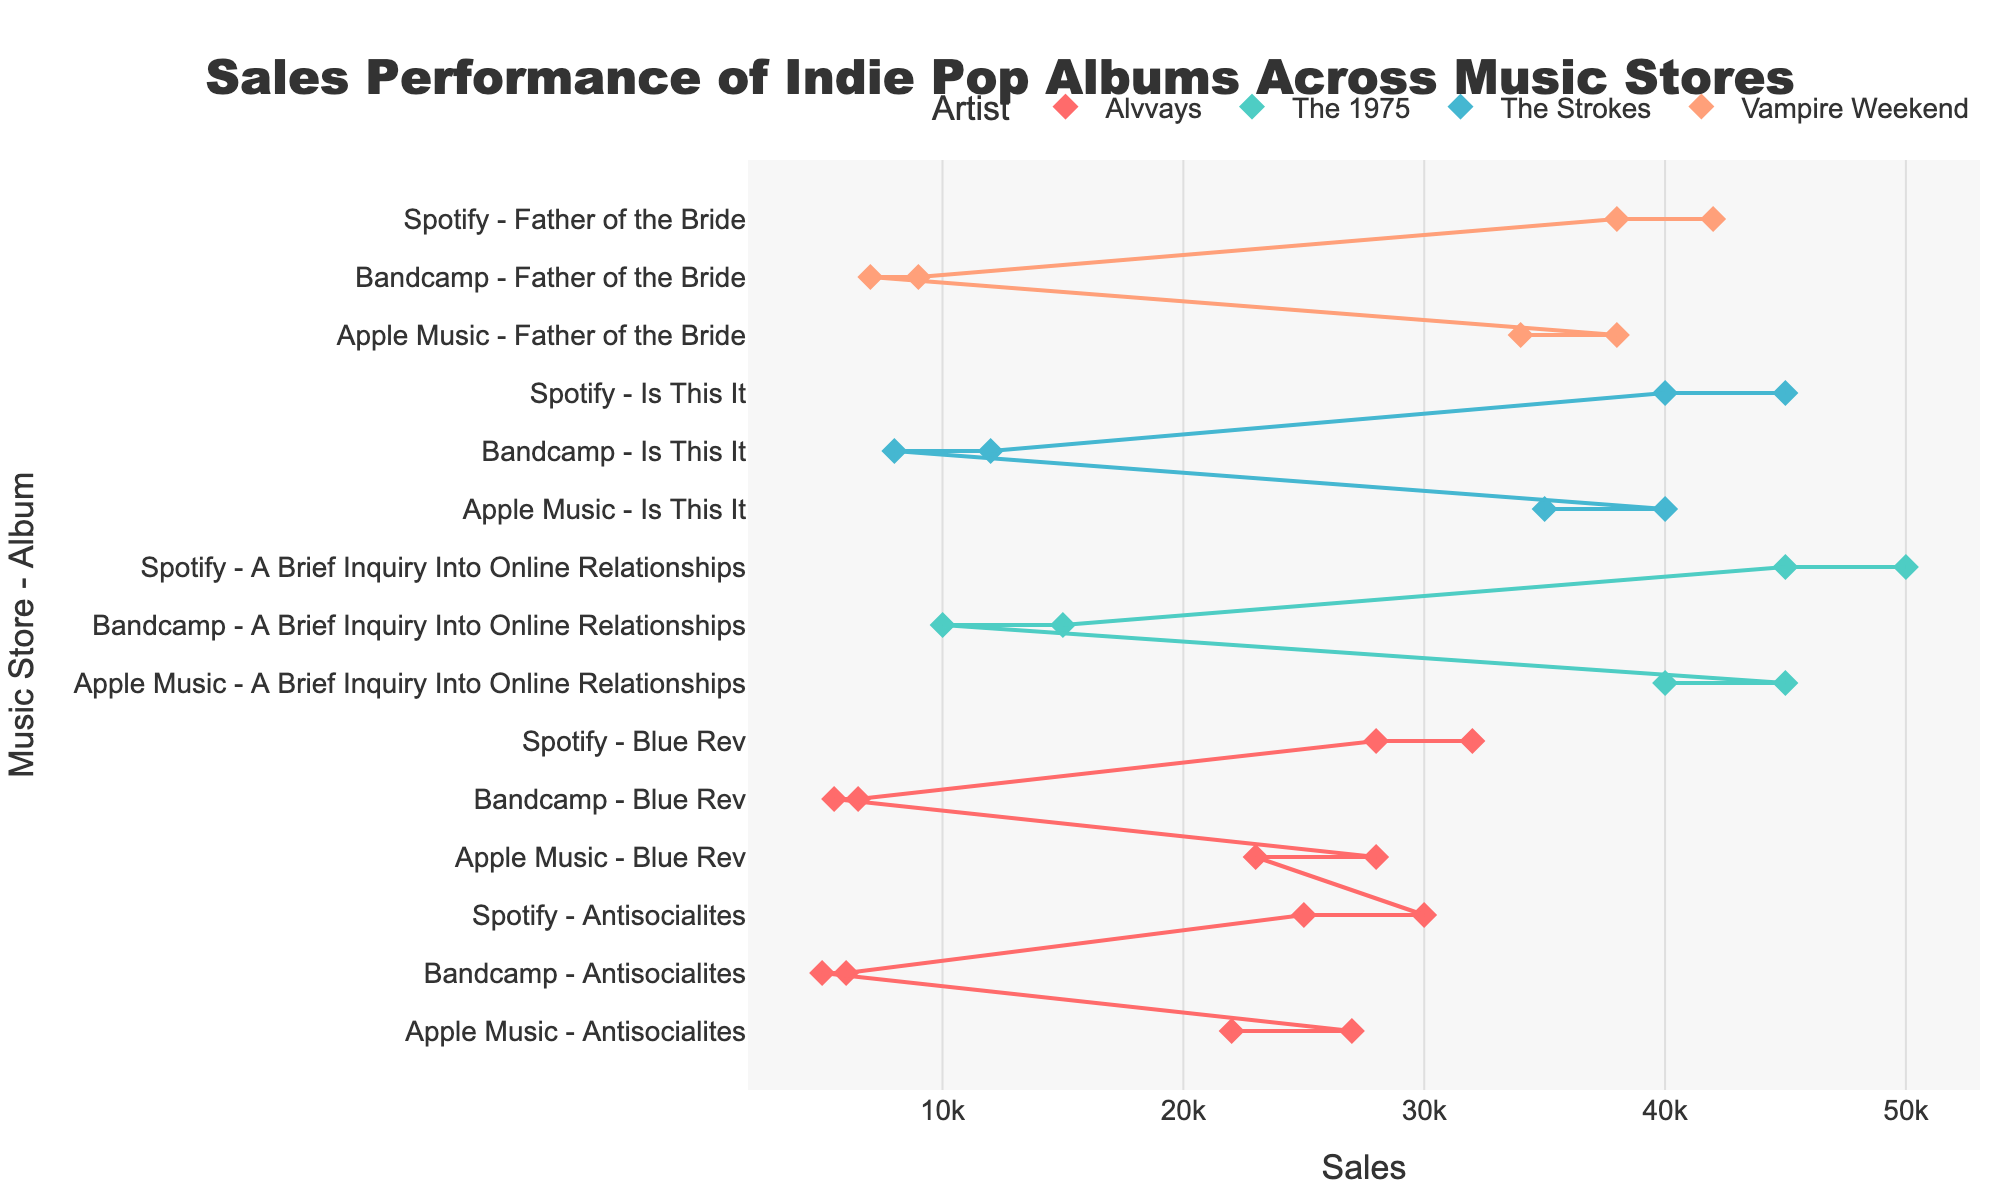What's the title of the figure? The title of the figure is prominently displayed at the top. It reads "Sales Performance of Indie Pop Albums Across Music Stores".
Answer: Sales Performance of Indie Pop Albums Across Music Stores Which artist has the highest maximum sales on Bandcamp? Look at the figure segment for Bandcamp and identify the album with the highest maximum sales. The 1975's "A Brief Inquiry Into Online Relationships" has the highest maximum sales on Bandcamp among all artists.
Answer: The 1975 What are the minimum and maximum sales for Alvvays' "Antisocialites" on Spotify? Locate the range of Alvvays' "Antisocialites" on Spotify from the figure. The minimum sales are 25,000 and the maximum sales are 30,000.
Answer: 25,000 to 30,000 What's the difference in maximum sales between The 1975's "A Brief Inquiry Into Online Relationships" on Spotify and Apple Music? Identify the maximum sales for The 1975's album on both Spotify and Apple Music. The values are 50,000 for Spotify and 45,000 for Apple Music. The difference is 50,000 - 45,000.
Answer: 5,000 Which music store has the smallest range of sales for Alvvays' "Blue Rev"? Determine the difference between the maximum and minimum sales for each music store. For "Blue Rev", these differences are 40,000 for Spotify, 50,000 for Apple Music, and 10,000 for Bandcamp. The smallest difference, hence smallest range, is with Bandcamp.
Answer: Bandcamp How do the sales of Alvvays' "Blue Rev" on Spotify compare to "Antisocialites" on the same platform? Compare the ranges on Spotify for both albums. "Blue Rev" has a minimum of 28,000 and a maximum of 32,000, while "Antisocialites" ranges from 25,000 to 30,000. "Blue Rev" has higher sales.
Answer: "Blue Rev" has higher sales What is the average of the maximum sales across all music stores for Vampire Weekend's "Father of the Bride"? Sum the maximum sales across all stores, then divide by the number of stores. The totals are 42,000 from Spotify, 38,000 from Apple Music, and 9,000 from Bandcamp (42,000 + 38,000 + 9,000) = 89,000. Divide by 3.
Answer: 29,666.67 Compared to Vampire Weekend, which artist has higher maximum sales on Apple Music but lower on Bandcamp for their album? Vampire Weekend's maximum sales on Apple Music and Bandcamp are 38,000 and 9,000 respectively. Comparing with other artists, The Strokes with "Is This It" have higher Apple Music sales (40,000) and lower Bandcamp sales (12,000).
Answer: The Strokes Which album has the largest sales range on Spotify? Determine the range (difference between maximum and minimum sales) on Spotify for each album. The 1975's "A Brief Inquiry Into Online Relationships" has the largest range with max 50,000 and min 45,000, which results in a range of 5,000.
Answer: A Brief Inquiry Into Online Relationships 